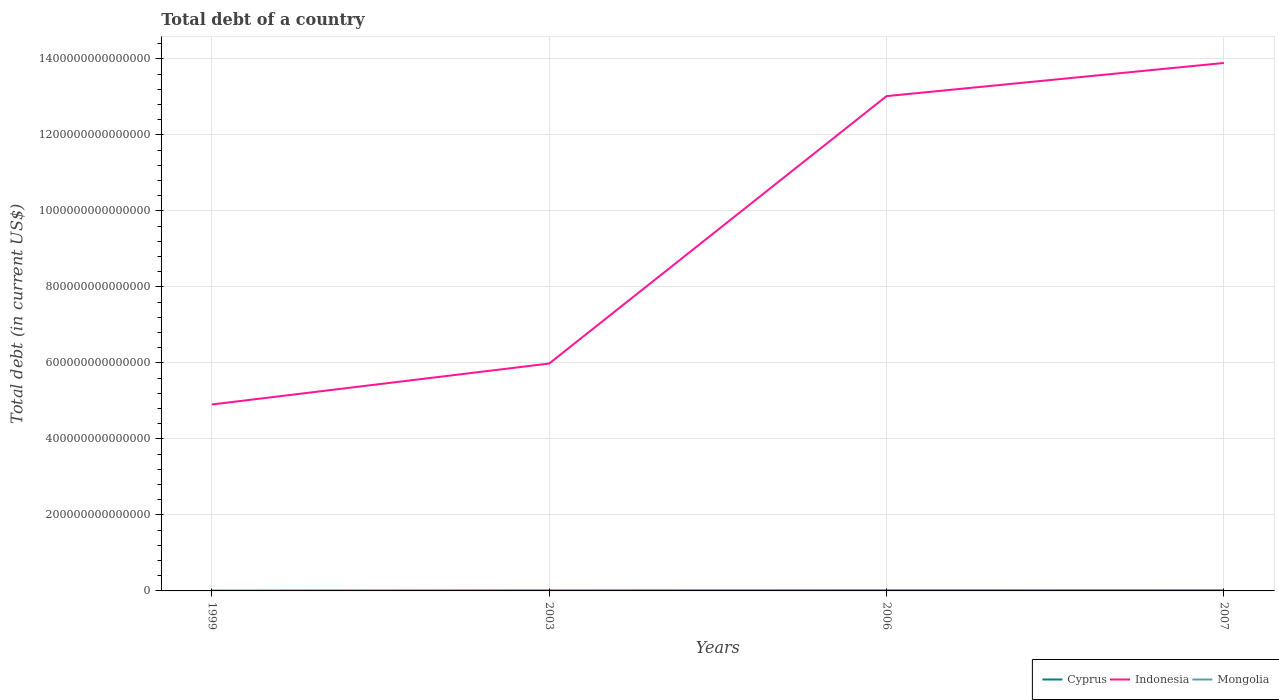How many different coloured lines are there?
Your response must be concise. 3. Is the number of lines equal to the number of legend labels?
Your answer should be very brief. Yes. Across all years, what is the maximum debt in Indonesia?
Provide a short and direct response. 4.91e+14. What is the total debt in Cyprus in the graph?
Provide a succinct answer. -6.95e+09. What is the difference between the highest and the second highest debt in Cyprus?
Offer a very short reply. 1.06e+1. Is the debt in Indonesia strictly greater than the debt in Cyprus over the years?
Your response must be concise. No. How many lines are there?
Give a very brief answer. 3. What is the difference between two consecutive major ticks on the Y-axis?
Offer a terse response. 2.00e+14. Does the graph contain any zero values?
Offer a terse response. No. Where does the legend appear in the graph?
Provide a succinct answer. Bottom right. How many legend labels are there?
Give a very brief answer. 3. How are the legend labels stacked?
Keep it short and to the point. Horizontal. What is the title of the graph?
Your answer should be very brief. Total debt of a country. Does "St. Lucia" appear as one of the legend labels in the graph?
Ensure brevity in your answer.  No. What is the label or title of the X-axis?
Offer a very short reply. Years. What is the label or title of the Y-axis?
Provide a short and direct response. Total debt (in current US$). What is the Total debt (in current US$) of Cyprus in 1999?
Keep it short and to the point. 1.41e+1. What is the Total debt (in current US$) of Indonesia in 1999?
Your answer should be very brief. 4.91e+14. What is the Total debt (in current US$) of Mongolia in 1999?
Provide a short and direct response. 9.07e+11. What is the Total debt (in current US$) of Cyprus in 2003?
Make the answer very short. 2.11e+1. What is the Total debt (in current US$) of Indonesia in 2003?
Your answer should be compact. 5.98e+14. What is the Total debt (in current US$) of Mongolia in 2003?
Provide a short and direct response. 1.75e+12. What is the Total debt (in current US$) of Cyprus in 2006?
Ensure brevity in your answer.  2.47e+1. What is the Total debt (in current US$) in Indonesia in 2006?
Offer a very short reply. 1.30e+15. What is the Total debt (in current US$) in Mongolia in 2006?
Your answer should be very brief. 2.03e+12. What is the Total debt (in current US$) of Cyprus in 2007?
Keep it short and to the point. 1.54e+1. What is the Total debt (in current US$) in Indonesia in 2007?
Ensure brevity in your answer.  1.39e+15. What is the Total debt (in current US$) in Mongolia in 2007?
Your answer should be compact. 2.16e+12. Across all years, what is the maximum Total debt (in current US$) in Cyprus?
Provide a succinct answer. 2.47e+1. Across all years, what is the maximum Total debt (in current US$) of Indonesia?
Provide a short and direct response. 1.39e+15. Across all years, what is the maximum Total debt (in current US$) in Mongolia?
Ensure brevity in your answer.  2.16e+12. Across all years, what is the minimum Total debt (in current US$) in Cyprus?
Your response must be concise. 1.41e+1. Across all years, what is the minimum Total debt (in current US$) in Indonesia?
Provide a succinct answer. 4.91e+14. Across all years, what is the minimum Total debt (in current US$) of Mongolia?
Provide a succinct answer. 9.07e+11. What is the total Total debt (in current US$) in Cyprus in the graph?
Your answer should be compact. 7.53e+1. What is the total Total debt (in current US$) in Indonesia in the graph?
Offer a terse response. 3.78e+15. What is the total Total debt (in current US$) of Mongolia in the graph?
Your answer should be compact. 6.85e+12. What is the difference between the Total debt (in current US$) of Cyprus in 1999 and that in 2003?
Ensure brevity in your answer.  -6.95e+09. What is the difference between the Total debt (in current US$) of Indonesia in 1999 and that in 2003?
Provide a succinct answer. -1.08e+14. What is the difference between the Total debt (in current US$) of Mongolia in 1999 and that in 2003?
Provide a succinct answer. -8.44e+11. What is the difference between the Total debt (in current US$) in Cyprus in 1999 and that in 2006?
Ensure brevity in your answer.  -1.06e+1. What is the difference between the Total debt (in current US$) of Indonesia in 1999 and that in 2006?
Your answer should be very brief. -8.11e+14. What is the difference between the Total debt (in current US$) in Mongolia in 1999 and that in 2006?
Make the answer very short. -1.13e+12. What is the difference between the Total debt (in current US$) in Cyprus in 1999 and that in 2007?
Ensure brevity in your answer.  -1.25e+09. What is the difference between the Total debt (in current US$) in Indonesia in 1999 and that in 2007?
Make the answer very short. -8.99e+14. What is the difference between the Total debt (in current US$) in Mongolia in 1999 and that in 2007?
Offer a terse response. -1.25e+12. What is the difference between the Total debt (in current US$) of Cyprus in 2003 and that in 2006?
Offer a very short reply. -3.67e+09. What is the difference between the Total debt (in current US$) in Indonesia in 2003 and that in 2006?
Your answer should be compact. -7.04e+14. What is the difference between the Total debt (in current US$) of Mongolia in 2003 and that in 2006?
Your answer should be compact. -2.83e+11. What is the difference between the Total debt (in current US$) in Cyprus in 2003 and that in 2007?
Offer a terse response. 5.70e+09. What is the difference between the Total debt (in current US$) in Indonesia in 2003 and that in 2007?
Give a very brief answer. -7.91e+14. What is the difference between the Total debt (in current US$) of Mongolia in 2003 and that in 2007?
Make the answer very short. -4.06e+11. What is the difference between the Total debt (in current US$) in Cyprus in 2006 and that in 2007?
Your answer should be very brief. 9.38e+09. What is the difference between the Total debt (in current US$) of Indonesia in 2006 and that in 2007?
Your answer should be compact. -8.72e+13. What is the difference between the Total debt (in current US$) in Mongolia in 2006 and that in 2007?
Give a very brief answer. -1.23e+11. What is the difference between the Total debt (in current US$) in Cyprus in 1999 and the Total debt (in current US$) in Indonesia in 2003?
Offer a terse response. -5.98e+14. What is the difference between the Total debt (in current US$) in Cyprus in 1999 and the Total debt (in current US$) in Mongolia in 2003?
Your answer should be very brief. -1.74e+12. What is the difference between the Total debt (in current US$) of Indonesia in 1999 and the Total debt (in current US$) of Mongolia in 2003?
Keep it short and to the point. 4.89e+14. What is the difference between the Total debt (in current US$) in Cyprus in 1999 and the Total debt (in current US$) in Indonesia in 2006?
Make the answer very short. -1.30e+15. What is the difference between the Total debt (in current US$) in Cyprus in 1999 and the Total debt (in current US$) in Mongolia in 2006?
Make the answer very short. -2.02e+12. What is the difference between the Total debt (in current US$) in Indonesia in 1999 and the Total debt (in current US$) in Mongolia in 2006?
Your response must be concise. 4.89e+14. What is the difference between the Total debt (in current US$) of Cyprus in 1999 and the Total debt (in current US$) of Indonesia in 2007?
Keep it short and to the point. -1.39e+15. What is the difference between the Total debt (in current US$) in Cyprus in 1999 and the Total debt (in current US$) in Mongolia in 2007?
Provide a succinct answer. -2.14e+12. What is the difference between the Total debt (in current US$) of Indonesia in 1999 and the Total debt (in current US$) of Mongolia in 2007?
Keep it short and to the point. 4.89e+14. What is the difference between the Total debt (in current US$) of Cyprus in 2003 and the Total debt (in current US$) of Indonesia in 2006?
Provide a short and direct response. -1.30e+15. What is the difference between the Total debt (in current US$) of Cyprus in 2003 and the Total debt (in current US$) of Mongolia in 2006?
Give a very brief answer. -2.01e+12. What is the difference between the Total debt (in current US$) of Indonesia in 2003 and the Total debt (in current US$) of Mongolia in 2006?
Offer a very short reply. 5.96e+14. What is the difference between the Total debt (in current US$) of Cyprus in 2003 and the Total debt (in current US$) of Indonesia in 2007?
Your answer should be very brief. -1.39e+15. What is the difference between the Total debt (in current US$) of Cyprus in 2003 and the Total debt (in current US$) of Mongolia in 2007?
Your answer should be compact. -2.14e+12. What is the difference between the Total debt (in current US$) of Indonesia in 2003 and the Total debt (in current US$) of Mongolia in 2007?
Your answer should be very brief. 5.96e+14. What is the difference between the Total debt (in current US$) in Cyprus in 2006 and the Total debt (in current US$) in Indonesia in 2007?
Keep it short and to the point. -1.39e+15. What is the difference between the Total debt (in current US$) in Cyprus in 2006 and the Total debt (in current US$) in Mongolia in 2007?
Provide a succinct answer. -2.13e+12. What is the difference between the Total debt (in current US$) in Indonesia in 2006 and the Total debt (in current US$) in Mongolia in 2007?
Your answer should be compact. 1.30e+15. What is the average Total debt (in current US$) in Cyprus per year?
Your answer should be compact. 1.88e+1. What is the average Total debt (in current US$) in Indonesia per year?
Offer a very short reply. 9.45e+14. What is the average Total debt (in current US$) of Mongolia per year?
Provide a short and direct response. 1.71e+12. In the year 1999, what is the difference between the Total debt (in current US$) in Cyprus and Total debt (in current US$) in Indonesia?
Your answer should be compact. -4.91e+14. In the year 1999, what is the difference between the Total debt (in current US$) of Cyprus and Total debt (in current US$) of Mongolia?
Offer a very short reply. -8.93e+11. In the year 1999, what is the difference between the Total debt (in current US$) of Indonesia and Total debt (in current US$) of Mongolia?
Provide a succinct answer. 4.90e+14. In the year 2003, what is the difference between the Total debt (in current US$) of Cyprus and Total debt (in current US$) of Indonesia?
Offer a terse response. -5.98e+14. In the year 2003, what is the difference between the Total debt (in current US$) of Cyprus and Total debt (in current US$) of Mongolia?
Make the answer very short. -1.73e+12. In the year 2003, what is the difference between the Total debt (in current US$) in Indonesia and Total debt (in current US$) in Mongolia?
Ensure brevity in your answer.  5.97e+14. In the year 2006, what is the difference between the Total debt (in current US$) of Cyprus and Total debt (in current US$) of Indonesia?
Provide a succinct answer. -1.30e+15. In the year 2006, what is the difference between the Total debt (in current US$) of Cyprus and Total debt (in current US$) of Mongolia?
Your answer should be very brief. -2.01e+12. In the year 2006, what is the difference between the Total debt (in current US$) in Indonesia and Total debt (in current US$) in Mongolia?
Your response must be concise. 1.30e+15. In the year 2007, what is the difference between the Total debt (in current US$) of Cyprus and Total debt (in current US$) of Indonesia?
Provide a short and direct response. -1.39e+15. In the year 2007, what is the difference between the Total debt (in current US$) of Cyprus and Total debt (in current US$) of Mongolia?
Provide a succinct answer. -2.14e+12. In the year 2007, what is the difference between the Total debt (in current US$) of Indonesia and Total debt (in current US$) of Mongolia?
Ensure brevity in your answer.  1.39e+15. What is the ratio of the Total debt (in current US$) of Cyprus in 1999 to that in 2003?
Give a very brief answer. 0.67. What is the ratio of the Total debt (in current US$) of Indonesia in 1999 to that in 2003?
Keep it short and to the point. 0.82. What is the ratio of the Total debt (in current US$) of Mongolia in 1999 to that in 2003?
Make the answer very short. 0.52. What is the ratio of the Total debt (in current US$) in Cyprus in 1999 to that in 2006?
Your response must be concise. 0.57. What is the ratio of the Total debt (in current US$) in Indonesia in 1999 to that in 2006?
Keep it short and to the point. 0.38. What is the ratio of the Total debt (in current US$) in Mongolia in 1999 to that in 2006?
Give a very brief answer. 0.45. What is the ratio of the Total debt (in current US$) in Cyprus in 1999 to that in 2007?
Keep it short and to the point. 0.92. What is the ratio of the Total debt (in current US$) in Indonesia in 1999 to that in 2007?
Provide a short and direct response. 0.35. What is the ratio of the Total debt (in current US$) of Mongolia in 1999 to that in 2007?
Keep it short and to the point. 0.42. What is the ratio of the Total debt (in current US$) in Cyprus in 2003 to that in 2006?
Ensure brevity in your answer.  0.85. What is the ratio of the Total debt (in current US$) of Indonesia in 2003 to that in 2006?
Provide a short and direct response. 0.46. What is the ratio of the Total debt (in current US$) of Mongolia in 2003 to that in 2006?
Give a very brief answer. 0.86. What is the ratio of the Total debt (in current US$) in Cyprus in 2003 to that in 2007?
Make the answer very short. 1.37. What is the ratio of the Total debt (in current US$) of Indonesia in 2003 to that in 2007?
Your answer should be compact. 0.43. What is the ratio of the Total debt (in current US$) in Mongolia in 2003 to that in 2007?
Provide a succinct answer. 0.81. What is the ratio of the Total debt (in current US$) of Cyprus in 2006 to that in 2007?
Make the answer very short. 1.61. What is the ratio of the Total debt (in current US$) in Indonesia in 2006 to that in 2007?
Your answer should be compact. 0.94. What is the ratio of the Total debt (in current US$) in Mongolia in 2006 to that in 2007?
Provide a succinct answer. 0.94. What is the difference between the highest and the second highest Total debt (in current US$) of Cyprus?
Keep it short and to the point. 3.67e+09. What is the difference between the highest and the second highest Total debt (in current US$) of Indonesia?
Make the answer very short. 8.72e+13. What is the difference between the highest and the second highest Total debt (in current US$) of Mongolia?
Provide a short and direct response. 1.23e+11. What is the difference between the highest and the lowest Total debt (in current US$) in Cyprus?
Offer a very short reply. 1.06e+1. What is the difference between the highest and the lowest Total debt (in current US$) of Indonesia?
Give a very brief answer. 8.99e+14. What is the difference between the highest and the lowest Total debt (in current US$) in Mongolia?
Your response must be concise. 1.25e+12. 